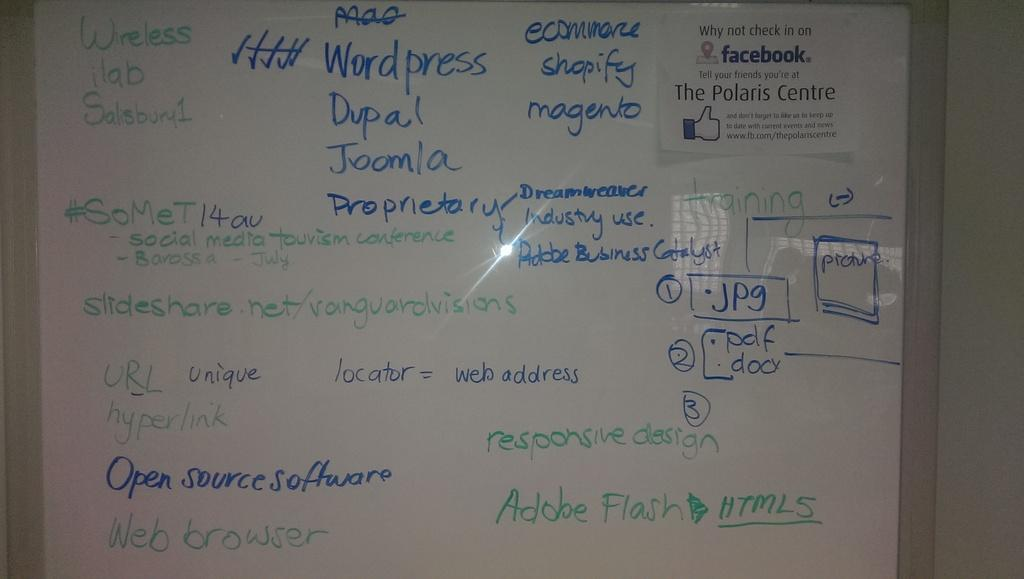<image>
Render a clear and concise summary of the photo. the word open is on a white board 